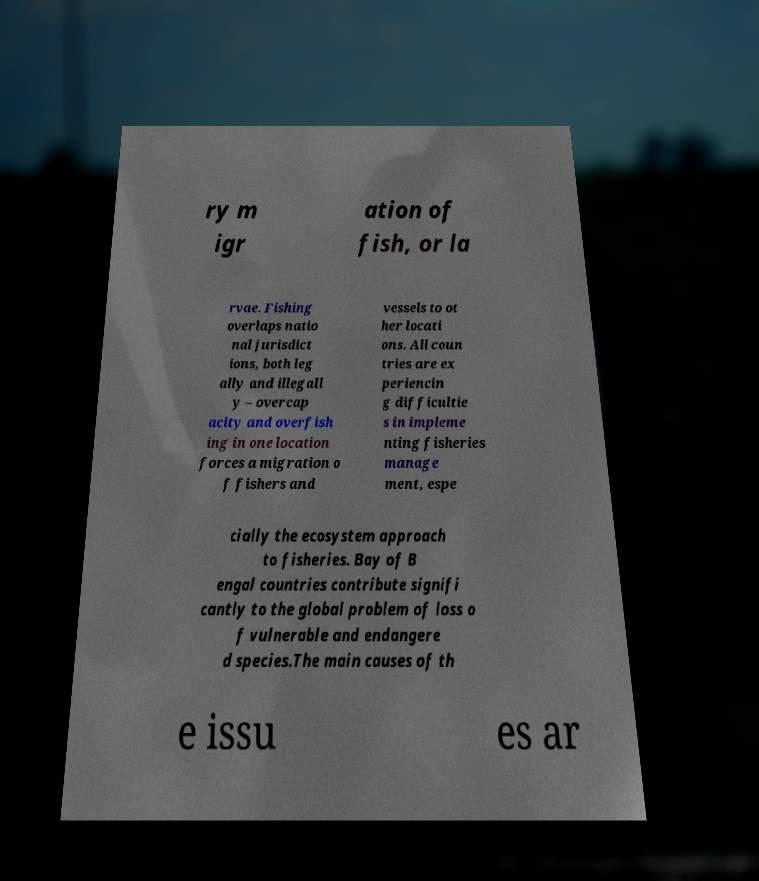Can you accurately transcribe the text from the provided image for me? ry m igr ation of fish, or la rvae. Fishing overlaps natio nal jurisdict ions, both leg ally and illegall y – overcap acity and overfish ing in one location forces a migration o f fishers and vessels to ot her locati ons. All coun tries are ex periencin g difficultie s in impleme nting fisheries manage ment, espe cially the ecosystem approach to fisheries. Bay of B engal countries contribute signifi cantly to the global problem of loss o f vulnerable and endangere d species.The main causes of th e issu es ar 